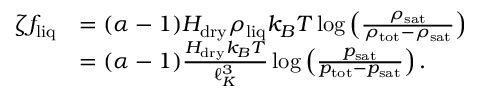<formula> <loc_0><loc_0><loc_500><loc_500>\begin{array} { r l } { \zeta f _ { l i q } } & { = ( \alpha - 1 ) H _ { d r y } \rho _ { l i q } k _ { B } T \log \left ( \frac { \rho _ { s a t } } { \rho _ { t o t } - \rho _ { s a t } } \right ) } \\ & { = ( \alpha - 1 ) \frac { H _ { d r y } k _ { B } T } { \ell _ { K } ^ { 3 } } \log \left ( \frac { p _ { s a t } } { p _ { t o t } - p _ { s a t } } \right ) . } \end{array}</formula> 